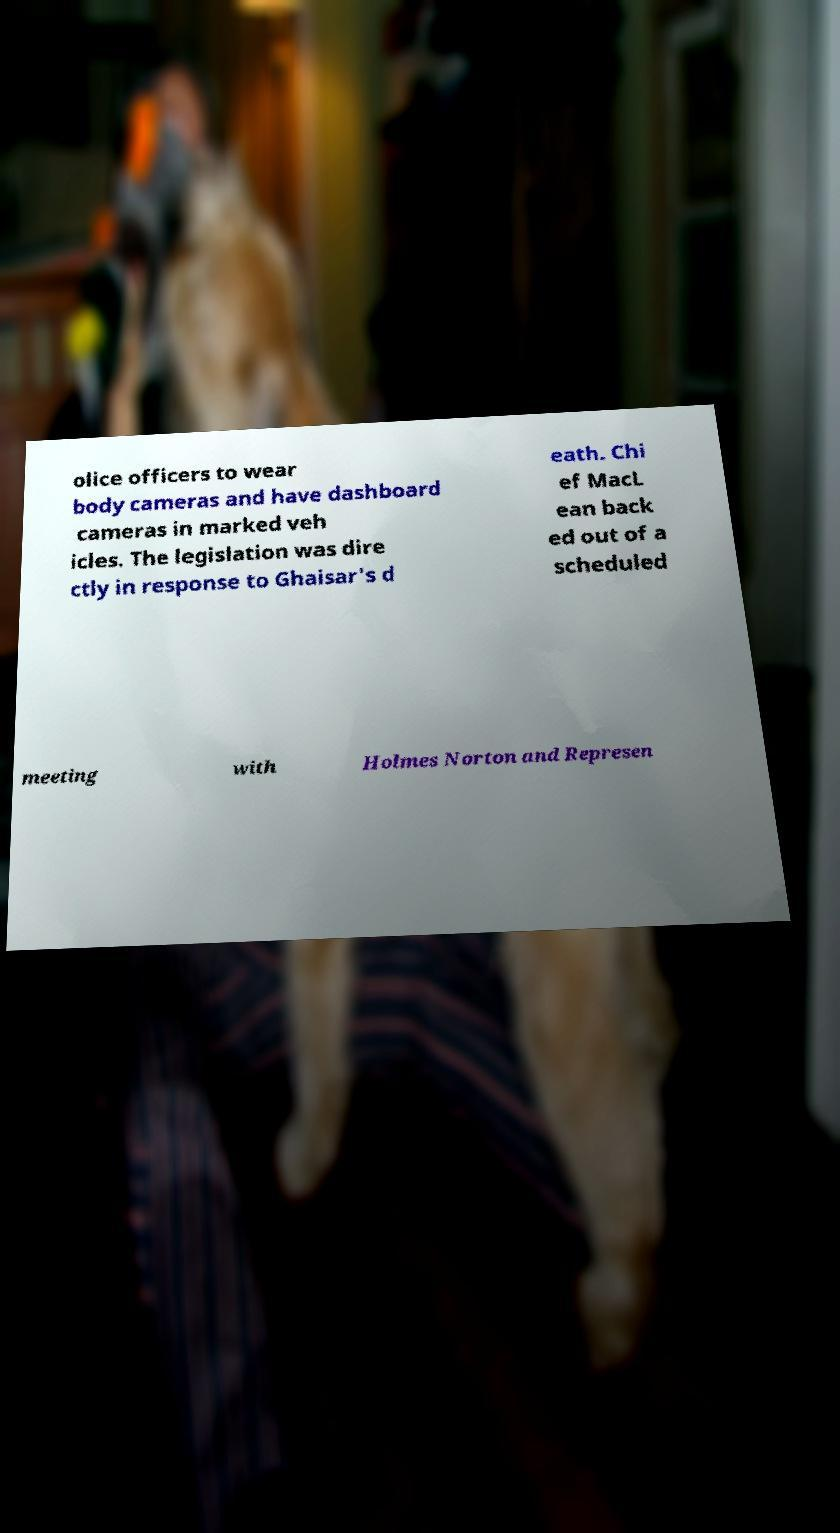Could you assist in decoding the text presented in this image and type it out clearly? olice officers to wear body cameras and have dashboard cameras in marked veh icles. The legislation was dire ctly in response to Ghaisar's d eath. Chi ef MacL ean back ed out of a scheduled meeting with Holmes Norton and Represen 